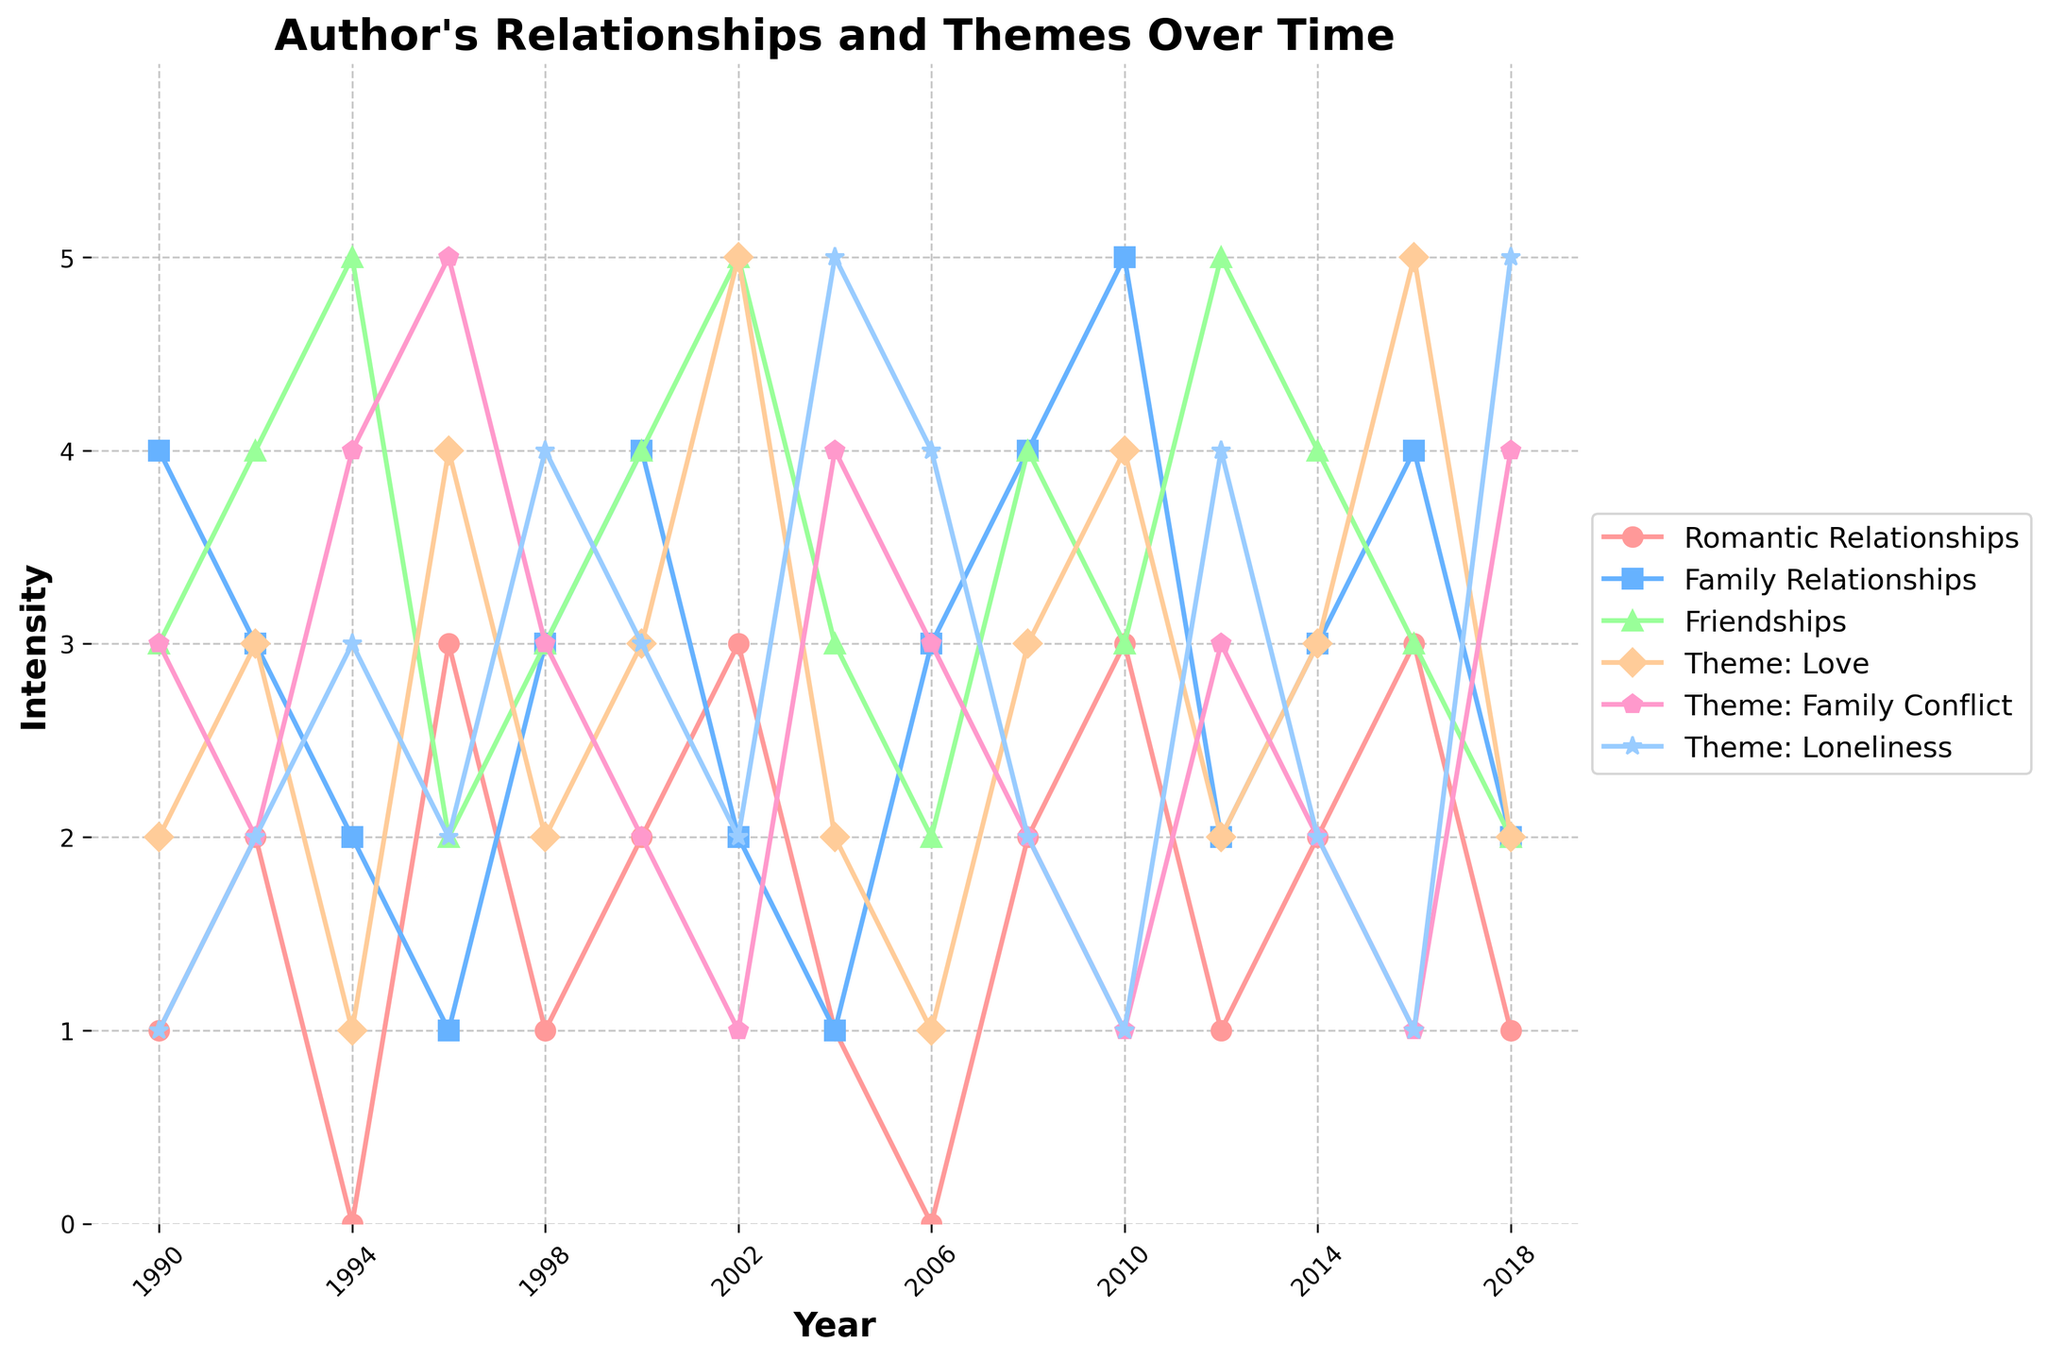How many themes show an increase when the author's romantic relationships increase from 1992 to 1994? From 1992 to 1994, Romantic Relationships decrease from 2 to 0. Themes 'Theme: Family Conflict' and 'Theme: Loneliness' both increase from 2 to 4 and from 2 to 3, respectively. Therefore, the number of themes that show an increase is 2.
Answer: 2 Which theme experiences the highest peak at any point in the data, and in which year does it occur? Checking the themes, 'Theme: Family Conflict' peaks at 5 in 1996. No other themes reach higher than 5 in any other year.
Answer: Theme: Family Conflict in 1996 Did the theme 'Loneliness' show an increasing trend when the 'Friendships' relationship decreased from 2012 to 2018? From 2012 to 2018, 'Friendships' decrease from 5 to 2. In parallel, 'Theme: Loneliness' increases from 4 to 5. Therefore, 'Theme: Loneliness' shows an increasing trend when 'Friendships' decrease.
Answer: Yes Which relationship was consistently the lowest compared to the other relationships from 1990 to 2018? Comparatively, 'Romantic Relationships' maintain lower values across the years. It starts at 1 in 1990 and often stays in the lower range (0-3) compared to the other relationships. It remains consistently lower when compared year by year.
Answer: Romantic Relationships In which years do 'Theme: Love' and 'Romantic Relationships' share the same value? Look at the graph for both 'Theme: Love' and 'Romantic Relationships' to identify the years they intersect. They both share the same value of 2 in the years 1992, 1998, 2008, 2014.
Answer: 1992, 1998, 2008, 2014 What is the average intensity value for 'Romantic Relationships' over the years? Calculate the sum of 'Romantic Relationships' values and divide by the number of years: (1+2+0+3+1+2+3+1+0+2+3+1+2+3+1)/15. The sum is 25, therefore the average is 25/15 ≈ 1.67.
Answer: 1.67 How did 'Family Relationships' compare to 'Family Conflict' theme in the year 2004? In 2004, 'Family Relationships' is 1 while 'Family Conflict' theme is 4. 'Family Conflict' is higher than 'Family Relationships' by 3 units.
Answer: Family Conflict higher by 3 units 